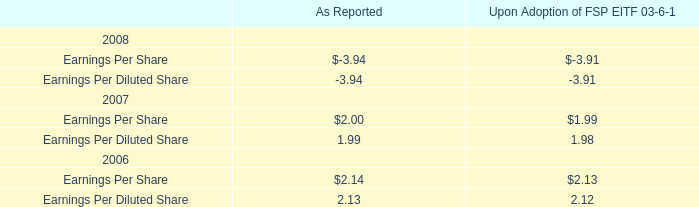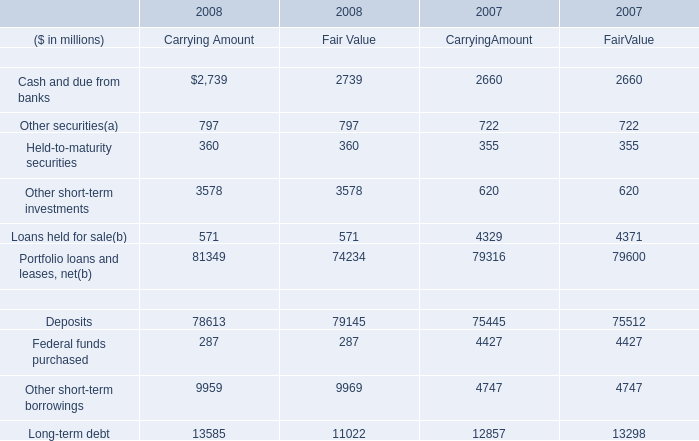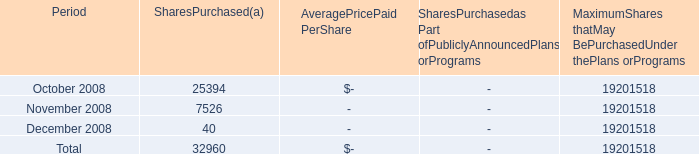What's the average of the Earnings Per Share for As Reported in the years where Held-to-maturity securities for Financial assets for Carrying Amount is positive? 
Computations: ((-3.94 + 2.00) / 2)
Answer: -0.97. 